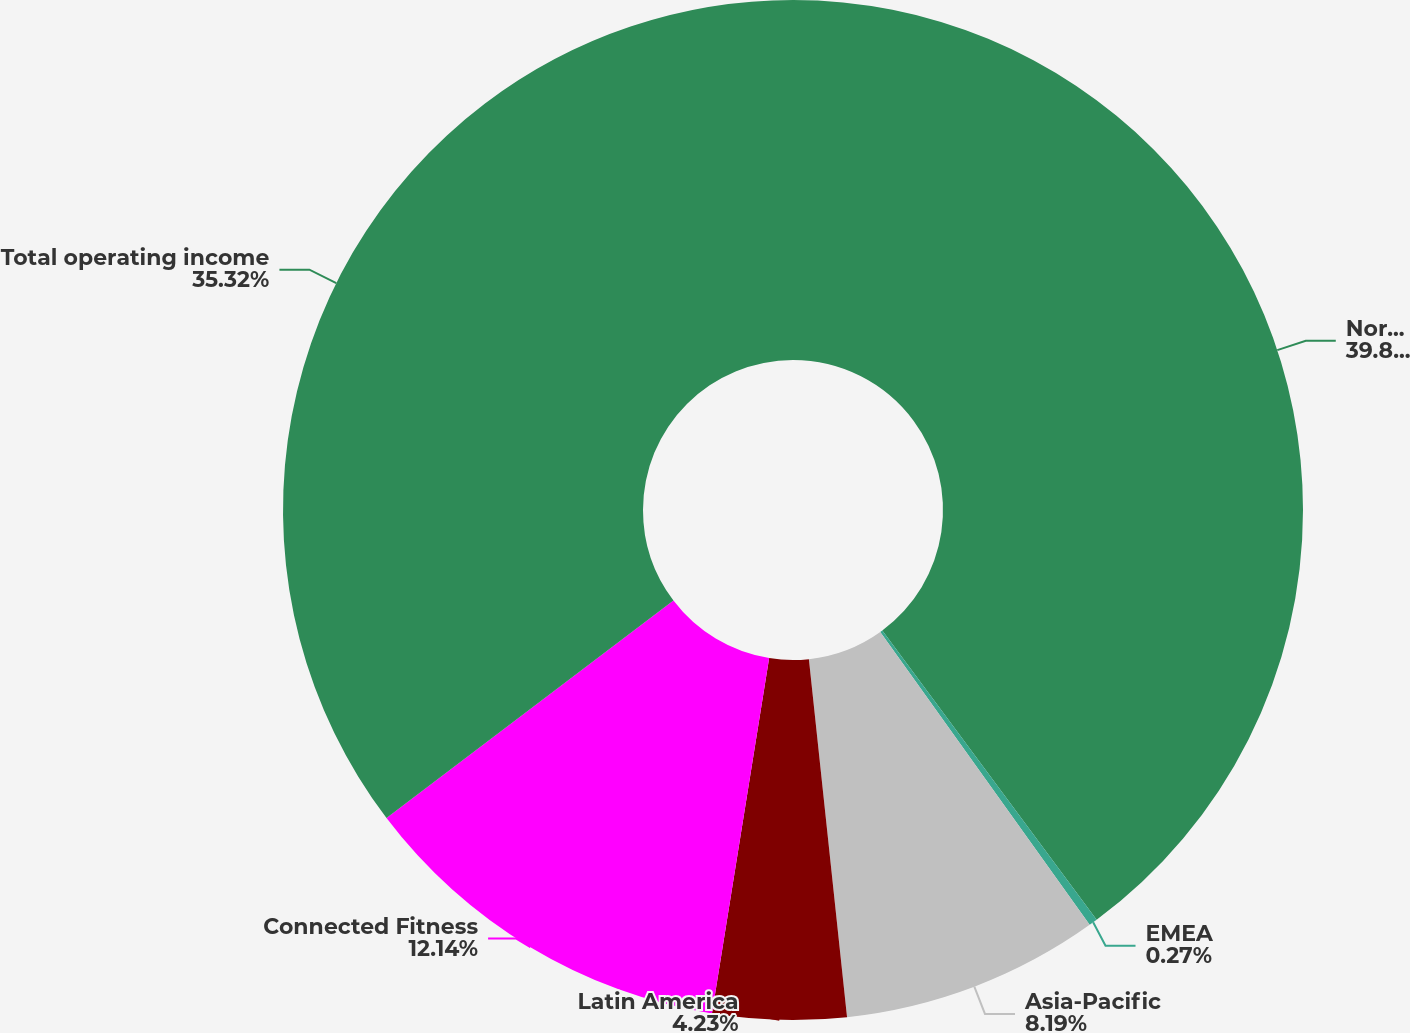Convert chart to OTSL. <chart><loc_0><loc_0><loc_500><loc_500><pie_chart><fcel>North America<fcel>EMEA<fcel>Asia-Pacific<fcel>Latin America<fcel>Connected Fitness<fcel>Total operating income<nl><fcel>39.85%<fcel>0.27%<fcel>8.19%<fcel>4.23%<fcel>12.14%<fcel>35.32%<nl></chart> 